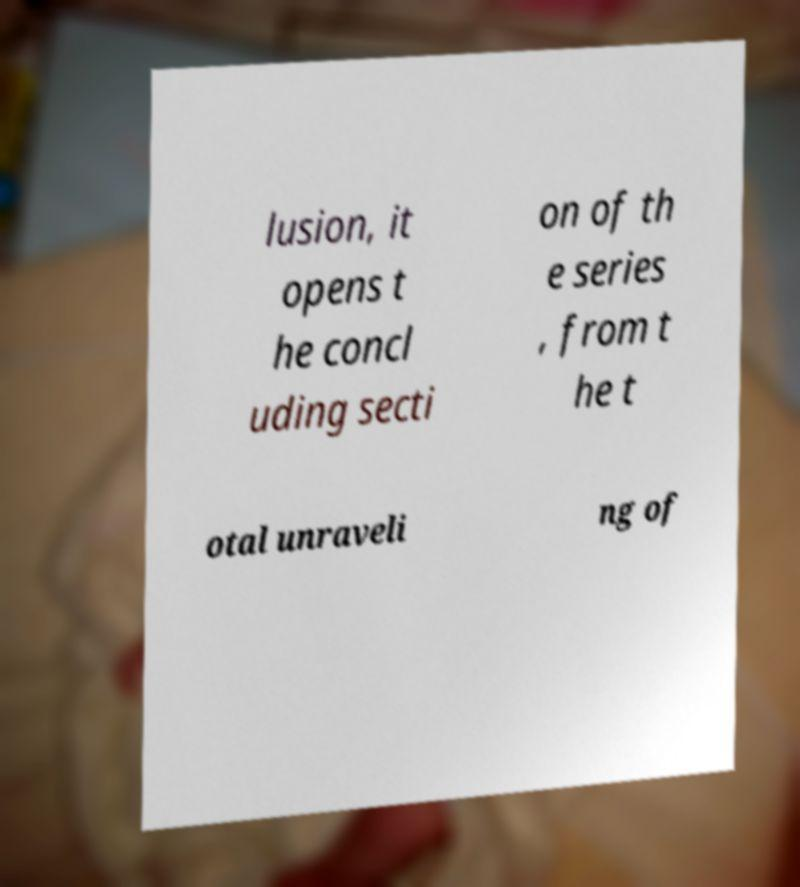Could you assist in decoding the text presented in this image and type it out clearly? lusion, it opens t he concl uding secti on of th e series , from t he t otal unraveli ng of 